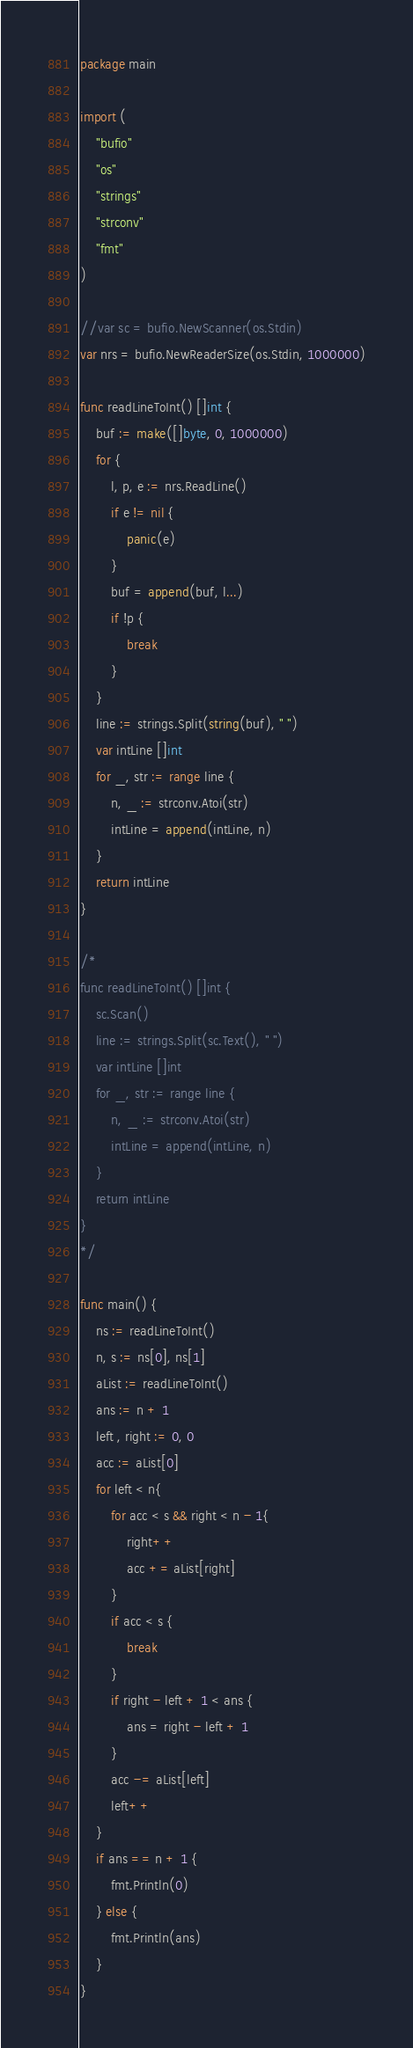<code> <loc_0><loc_0><loc_500><loc_500><_Go_>package main

import (
    "bufio"
    "os"
    "strings"
    "strconv"
    "fmt"
)

//var sc = bufio.NewScanner(os.Stdin)
var nrs = bufio.NewReaderSize(os.Stdin, 1000000)

func readLineToInt() []int {
    buf := make([]byte, 0, 1000000)
    for {
        l, p, e := nrs.ReadLine()
        if e != nil {
            panic(e)
        }
        buf = append(buf, l...)
        if !p {
            break
        }
    }
    line := strings.Split(string(buf), " ")
    var intLine []int
    for _, str := range line {
        n, _ := strconv.Atoi(str)
        intLine = append(intLine, n)
    }
    return intLine
}

/*
func readLineToInt() []int {
    sc.Scan()
    line := strings.Split(sc.Text(), " ")
    var intLine []int
    for _, str := range line {
        n, _ := strconv.Atoi(str)
        intLine = append(intLine, n)
    }
    return intLine
}
*/

func main() {
    ns := readLineToInt()
    n, s := ns[0], ns[1]
    aList := readLineToInt()
    ans := n + 1
    left , right := 0, 0
    acc := aList[0]
    for left < n{
        for acc < s && right < n - 1{
            right++
            acc += aList[right]
        }
        if acc < s {
            break
        }
        if right - left + 1 < ans {
            ans = right - left + 1
        }
        acc -= aList[left]
        left++
    }
    if ans == n + 1 {
        fmt.Println(0)
    } else {
        fmt.Println(ans)
    }
}
</code> 